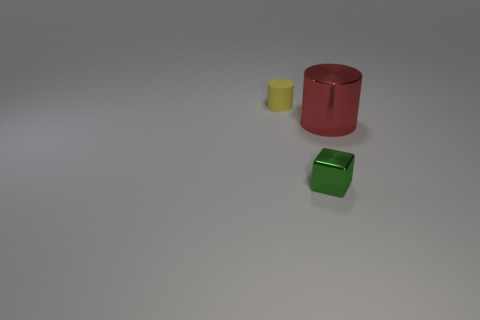Add 1 small matte cylinders. How many objects exist? 4 Subtract all cylinders. How many objects are left? 1 Subtract 0 blue cylinders. How many objects are left? 3 Subtract all big matte cylinders. Subtract all red metallic cylinders. How many objects are left? 2 Add 2 big red objects. How many big red objects are left? 3 Add 2 big green cubes. How many big green cubes exist? 2 